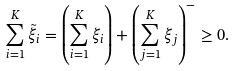Convert formula to latex. <formula><loc_0><loc_0><loc_500><loc_500>\sum _ { i = 1 } ^ { K } \tilde { \xi } _ { i } = \left ( \sum _ { i = 1 } ^ { K } \xi _ { i } \right ) + \left ( \sum _ { j = 1 } ^ { K } \xi _ { j } \right ) ^ { - } \geq 0 .</formula> 